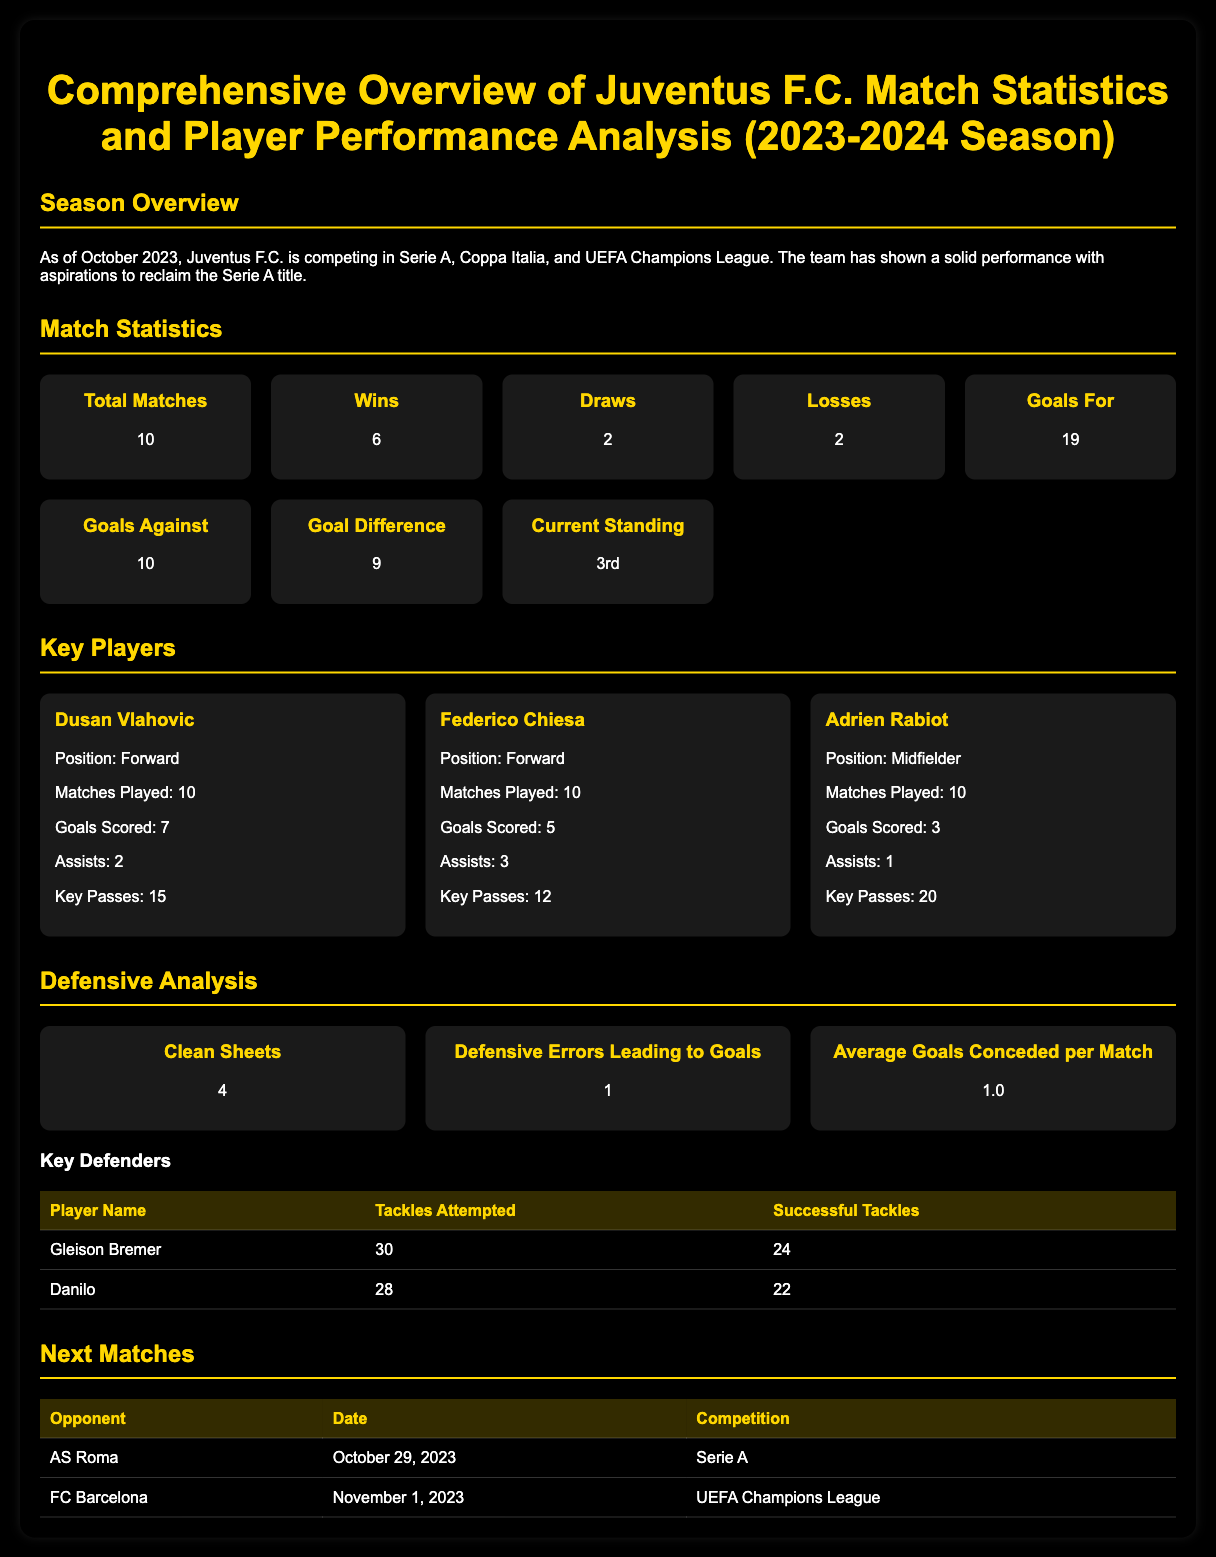What is the current standing of Juventus F.C.? The current standing is stated under the match statistics section of the document, indicating the team's position in the league.
Answer: 3rd How many matches has Juventus F.C. played this season? This information is provided in the match statistics section where the total matches are listed.
Answer: 10 Who is the player with the most goals scored? The player with the most goals is identified in the key players section, highlighting their goal tally.
Answer: Dusan Vlahovic What is the average goals conceded per match? The average goals conceded per match can be found in the defensive analysis section of the document, which provides key defensive metrics.
Answer: 1.0 When is Juventus' match against FC Barcelona? The match date is included in the next matches table, which lists upcoming fixtures for the team.
Answer: November 1, 2023 How many assists did Federico Chiesa record? The number of assists by Federico Chiesa is specified within the player card dedicated to him in the key players section.
Answer: 3 What is the total number of goals scored by Juventus F.C. so far? This figure is found in the match statistics section, where goals for and against are recorded.
Answer: 19 How many clean sheets has Juventus F.C. achieved? The number of clean sheets is detailed in the defensive analysis section, indicating their defensive performance.
Answer: 4 What is the position of Gleison Bremer in the team? Although not explicitly stated, his role can be inferred from the key defenders table presenting defensive statistics.
Answer: Defender 